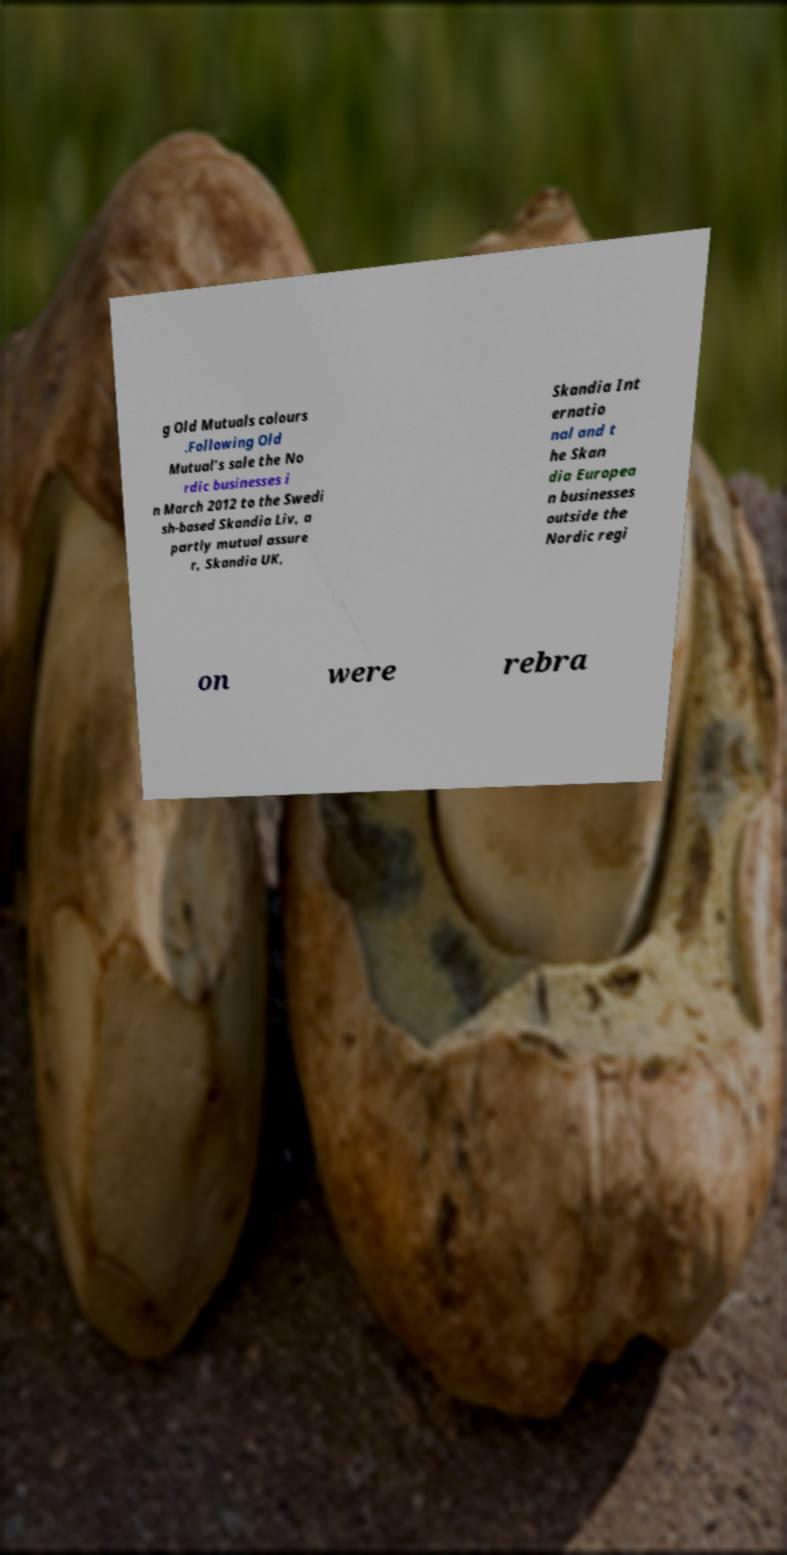Could you assist in decoding the text presented in this image and type it out clearly? g Old Mutuals colours .Following Old Mutual’s sale the No rdic businesses i n March 2012 to the Swedi sh-based Skandia Liv, a partly mutual assure r, Skandia UK, Skandia Int ernatio nal and t he Skan dia Europea n businesses outside the Nordic regi on were rebra 